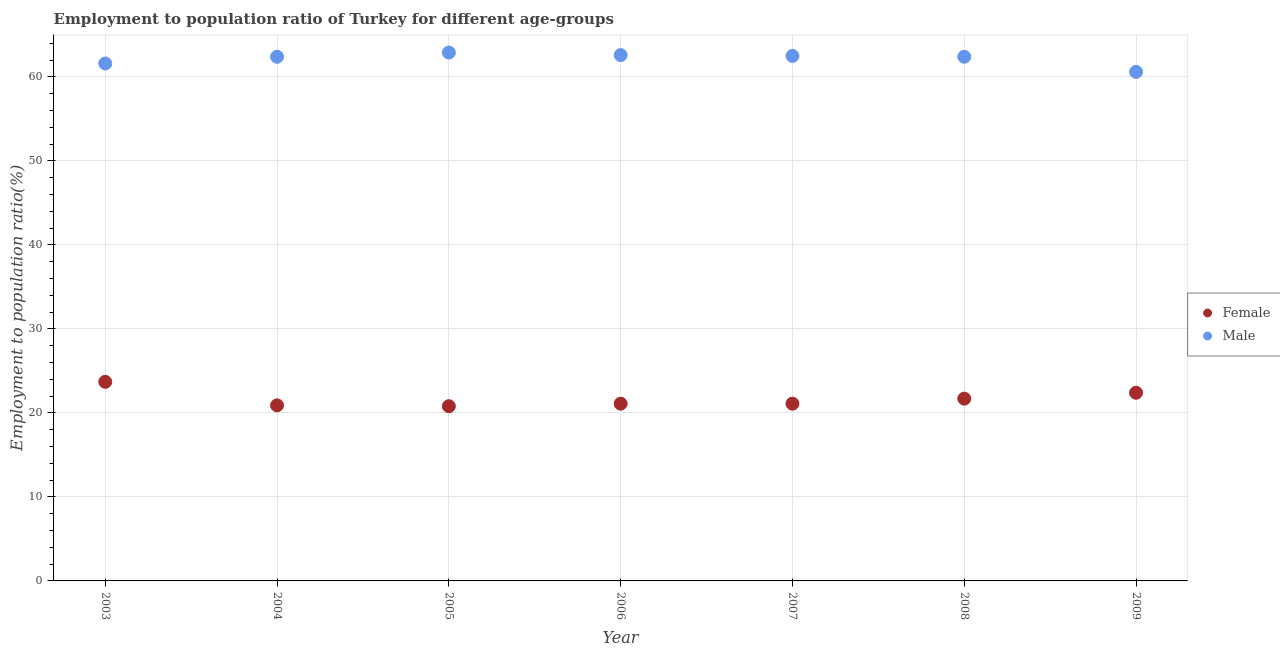Is the number of dotlines equal to the number of legend labels?
Your answer should be compact. Yes. What is the employment to population ratio(male) in 2008?
Give a very brief answer. 62.4. Across all years, what is the maximum employment to population ratio(female)?
Your answer should be very brief. 23.7. Across all years, what is the minimum employment to population ratio(female)?
Give a very brief answer. 20.8. In which year was the employment to population ratio(female) maximum?
Give a very brief answer. 2003. What is the total employment to population ratio(female) in the graph?
Your response must be concise. 151.7. What is the difference between the employment to population ratio(female) in 2003 and that in 2005?
Your answer should be compact. 2.9. What is the difference between the employment to population ratio(female) in 2008 and the employment to population ratio(male) in 2009?
Give a very brief answer. -38.9. What is the average employment to population ratio(female) per year?
Give a very brief answer. 21.67. In the year 2003, what is the difference between the employment to population ratio(female) and employment to population ratio(male)?
Provide a short and direct response. -37.9. In how many years, is the employment to population ratio(female) greater than 46 %?
Offer a terse response. 0. What is the ratio of the employment to population ratio(male) in 2004 to that in 2008?
Offer a very short reply. 1. Is the employment to population ratio(male) in 2004 less than that in 2005?
Offer a terse response. Yes. Is the difference between the employment to population ratio(female) in 2004 and 2007 greater than the difference between the employment to population ratio(male) in 2004 and 2007?
Make the answer very short. No. What is the difference between the highest and the second highest employment to population ratio(female)?
Keep it short and to the point. 1.3. What is the difference between the highest and the lowest employment to population ratio(female)?
Provide a short and direct response. 2.9. In how many years, is the employment to population ratio(female) greater than the average employment to population ratio(female) taken over all years?
Offer a terse response. 3. Is the employment to population ratio(female) strictly greater than the employment to population ratio(male) over the years?
Provide a short and direct response. No. How many years are there in the graph?
Your response must be concise. 7. Does the graph contain grids?
Provide a short and direct response. Yes. How are the legend labels stacked?
Your answer should be very brief. Vertical. What is the title of the graph?
Keep it short and to the point. Employment to population ratio of Turkey for different age-groups. What is the label or title of the Y-axis?
Provide a succinct answer. Employment to population ratio(%). What is the Employment to population ratio(%) of Female in 2003?
Ensure brevity in your answer.  23.7. What is the Employment to population ratio(%) in Male in 2003?
Provide a short and direct response. 61.6. What is the Employment to population ratio(%) of Female in 2004?
Your response must be concise. 20.9. What is the Employment to population ratio(%) in Male in 2004?
Provide a succinct answer. 62.4. What is the Employment to population ratio(%) in Female in 2005?
Ensure brevity in your answer.  20.8. What is the Employment to population ratio(%) of Male in 2005?
Offer a terse response. 62.9. What is the Employment to population ratio(%) of Female in 2006?
Provide a succinct answer. 21.1. What is the Employment to population ratio(%) in Male in 2006?
Your answer should be compact. 62.6. What is the Employment to population ratio(%) of Female in 2007?
Offer a very short reply. 21.1. What is the Employment to population ratio(%) in Male in 2007?
Offer a very short reply. 62.5. What is the Employment to population ratio(%) of Female in 2008?
Your response must be concise. 21.7. What is the Employment to population ratio(%) of Male in 2008?
Give a very brief answer. 62.4. What is the Employment to population ratio(%) in Female in 2009?
Ensure brevity in your answer.  22.4. What is the Employment to population ratio(%) in Male in 2009?
Your answer should be compact. 60.6. Across all years, what is the maximum Employment to population ratio(%) in Female?
Provide a succinct answer. 23.7. Across all years, what is the maximum Employment to population ratio(%) in Male?
Provide a short and direct response. 62.9. Across all years, what is the minimum Employment to population ratio(%) in Female?
Ensure brevity in your answer.  20.8. Across all years, what is the minimum Employment to population ratio(%) in Male?
Give a very brief answer. 60.6. What is the total Employment to population ratio(%) in Female in the graph?
Offer a very short reply. 151.7. What is the total Employment to population ratio(%) in Male in the graph?
Your answer should be compact. 435. What is the difference between the Employment to population ratio(%) of Female in 2003 and that in 2006?
Provide a succinct answer. 2.6. What is the difference between the Employment to population ratio(%) in Male in 2003 and that in 2007?
Ensure brevity in your answer.  -0.9. What is the difference between the Employment to population ratio(%) of Male in 2003 and that in 2008?
Your answer should be compact. -0.8. What is the difference between the Employment to population ratio(%) in Female in 2004 and that in 2006?
Keep it short and to the point. -0.2. What is the difference between the Employment to population ratio(%) in Female in 2004 and that in 2008?
Offer a terse response. -0.8. What is the difference between the Employment to population ratio(%) of Female in 2004 and that in 2009?
Offer a terse response. -1.5. What is the difference between the Employment to population ratio(%) in Male in 2004 and that in 2009?
Offer a terse response. 1.8. What is the difference between the Employment to population ratio(%) of Male in 2005 and that in 2007?
Provide a short and direct response. 0.4. What is the difference between the Employment to population ratio(%) in Female in 2005 and that in 2008?
Your answer should be compact. -0.9. What is the difference between the Employment to population ratio(%) in Male in 2005 and that in 2008?
Keep it short and to the point. 0.5. What is the difference between the Employment to population ratio(%) in Male in 2006 and that in 2007?
Your response must be concise. 0.1. What is the difference between the Employment to population ratio(%) in Female in 2006 and that in 2008?
Offer a very short reply. -0.6. What is the difference between the Employment to population ratio(%) in Female in 2006 and that in 2009?
Keep it short and to the point. -1.3. What is the difference between the Employment to population ratio(%) in Male in 2006 and that in 2009?
Your answer should be compact. 2. What is the difference between the Employment to population ratio(%) in Female in 2007 and that in 2009?
Make the answer very short. -1.3. What is the difference between the Employment to population ratio(%) in Male in 2007 and that in 2009?
Keep it short and to the point. 1.9. What is the difference between the Employment to population ratio(%) of Male in 2008 and that in 2009?
Provide a succinct answer. 1.8. What is the difference between the Employment to population ratio(%) in Female in 2003 and the Employment to population ratio(%) in Male in 2004?
Provide a short and direct response. -38.7. What is the difference between the Employment to population ratio(%) in Female in 2003 and the Employment to population ratio(%) in Male in 2005?
Provide a short and direct response. -39.2. What is the difference between the Employment to population ratio(%) of Female in 2003 and the Employment to population ratio(%) of Male in 2006?
Give a very brief answer. -38.9. What is the difference between the Employment to population ratio(%) in Female in 2003 and the Employment to population ratio(%) in Male in 2007?
Give a very brief answer. -38.8. What is the difference between the Employment to population ratio(%) of Female in 2003 and the Employment to population ratio(%) of Male in 2008?
Make the answer very short. -38.7. What is the difference between the Employment to population ratio(%) of Female in 2003 and the Employment to population ratio(%) of Male in 2009?
Ensure brevity in your answer.  -36.9. What is the difference between the Employment to population ratio(%) in Female in 2004 and the Employment to population ratio(%) in Male in 2005?
Offer a terse response. -42. What is the difference between the Employment to population ratio(%) of Female in 2004 and the Employment to population ratio(%) of Male in 2006?
Keep it short and to the point. -41.7. What is the difference between the Employment to population ratio(%) in Female in 2004 and the Employment to population ratio(%) in Male in 2007?
Provide a short and direct response. -41.6. What is the difference between the Employment to population ratio(%) of Female in 2004 and the Employment to population ratio(%) of Male in 2008?
Provide a short and direct response. -41.5. What is the difference between the Employment to population ratio(%) in Female in 2004 and the Employment to population ratio(%) in Male in 2009?
Provide a succinct answer. -39.7. What is the difference between the Employment to population ratio(%) of Female in 2005 and the Employment to population ratio(%) of Male in 2006?
Provide a short and direct response. -41.8. What is the difference between the Employment to population ratio(%) of Female in 2005 and the Employment to population ratio(%) of Male in 2007?
Provide a succinct answer. -41.7. What is the difference between the Employment to population ratio(%) of Female in 2005 and the Employment to population ratio(%) of Male in 2008?
Your answer should be compact. -41.6. What is the difference between the Employment to population ratio(%) in Female in 2005 and the Employment to population ratio(%) in Male in 2009?
Ensure brevity in your answer.  -39.8. What is the difference between the Employment to population ratio(%) of Female in 2006 and the Employment to population ratio(%) of Male in 2007?
Give a very brief answer. -41.4. What is the difference between the Employment to population ratio(%) in Female in 2006 and the Employment to population ratio(%) in Male in 2008?
Provide a succinct answer. -41.3. What is the difference between the Employment to population ratio(%) in Female in 2006 and the Employment to population ratio(%) in Male in 2009?
Make the answer very short. -39.5. What is the difference between the Employment to population ratio(%) of Female in 2007 and the Employment to population ratio(%) of Male in 2008?
Your answer should be very brief. -41.3. What is the difference between the Employment to population ratio(%) in Female in 2007 and the Employment to population ratio(%) in Male in 2009?
Keep it short and to the point. -39.5. What is the difference between the Employment to population ratio(%) in Female in 2008 and the Employment to population ratio(%) in Male in 2009?
Your answer should be compact. -38.9. What is the average Employment to population ratio(%) in Female per year?
Your answer should be compact. 21.67. What is the average Employment to population ratio(%) in Male per year?
Give a very brief answer. 62.14. In the year 2003, what is the difference between the Employment to population ratio(%) of Female and Employment to population ratio(%) of Male?
Give a very brief answer. -37.9. In the year 2004, what is the difference between the Employment to population ratio(%) in Female and Employment to population ratio(%) in Male?
Keep it short and to the point. -41.5. In the year 2005, what is the difference between the Employment to population ratio(%) of Female and Employment to population ratio(%) of Male?
Ensure brevity in your answer.  -42.1. In the year 2006, what is the difference between the Employment to population ratio(%) in Female and Employment to population ratio(%) in Male?
Keep it short and to the point. -41.5. In the year 2007, what is the difference between the Employment to population ratio(%) of Female and Employment to population ratio(%) of Male?
Keep it short and to the point. -41.4. In the year 2008, what is the difference between the Employment to population ratio(%) in Female and Employment to population ratio(%) in Male?
Provide a succinct answer. -40.7. In the year 2009, what is the difference between the Employment to population ratio(%) in Female and Employment to population ratio(%) in Male?
Offer a very short reply. -38.2. What is the ratio of the Employment to population ratio(%) in Female in 2003 to that in 2004?
Make the answer very short. 1.13. What is the ratio of the Employment to population ratio(%) in Male in 2003 to that in 2004?
Your answer should be very brief. 0.99. What is the ratio of the Employment to population ratio(%) in Female in 2003 to that in 2005?
Your response must be concise. 1.14. What is the ratio of the Employment to population ratio(%) of Male in 2003 to that in 2005?
Make the answer very short. 0.98. What is the ratio of the Employment to population ratio(%) in Female in 2003 to that in 2006?
Provide a succinct answer. 1.12. What is the ratio of the Employment to population ratio(%) of Male in 2003 to that in 2006?
Provide a short and direct response. 0.98. What is the ratio of the Employment to population ratio(%) in Female in 2003 to that in 2007?
Provide a short and direct response. 1.12. What is the ratio of the Employment to population ratio(%) in Male in 2003 to that in 2007?
Provide a short and direct response. 0.99. What is the ratio of the Employment to population ratio(%) in Female in 2003 to that in 2008?
Your answer should be very brief. 1.09. What is the ratio of the Employment to population ratio(%) in Male in 2003 to that in 2008?
Your response must be concise. 0.99. What is the ratio of the Employment to population ratio(%) in Female in 2003 to that in 2009?
Provide a short and direct response. 1.06. What is the ratio of the Employment to population ratio(%) of Male in 2003 to that in 2009?
Keep it short and to the point. 1.02. What is the ratio of the Employment to population ratio(%) of Male in 2004 to that in 2005?
Provide a succinct answer. 0.99. What is the ratio of the Employment to population ratio(%) of Female in 2004 to that in 2006?
Keep it short and to the point. 0.99. What is the ratio of the Employment to population ratio(%) of Female in 2004 to that in 2008?
Your answer should be compact. 0.96. What is the ratio of the Employment to population ratio(%) in Female in 2004 to that in 2009?
Offer a very short reply. 0.93. What is the ratio of the Employment to population ratio(%) of Male in 2004 to that in 2009?
Make the answer very short. 1.03. What is the ratio of the Employment to population ratio(%) of Female in 2005 to that in 2006?
Your answer should be compact. 0.99. What is the ratio of the Employment to population ratio(%) in Female in 2005 to that in 2007?
Provide a succinct answer. 0.99. What is the ratio of the Employment to population ratio(%) of Male in 2005 to that in 2007?
Give a very brief answer. 1.01. What is the ratio of the Employment to population ratio(%) of Female in 2005 to that in 2008?
Your answer should be very brief. 0.96. What is the ratio of the Employment to population ratio(%) in Female in 2005 to that in 2009?
Your response must be concise. 0.93. What is the ratio of the Employment to population ratio(%) of Male in 2005 to that in 2009?
Your answer should be compact. 1.04. What is the ratio of the Employment to population ratio(%) in Male in 2006 to that in 2007?
Offer a terse response. 1. What is the ratio of the Employment to population ratio(%) of Female in 2006 to that in 2008?
Offer a terse response. 0.97. What is the ratio of the Employment to population ratio(%) in Male in 2006 to that in 2008?
Your answer should be very brief. 1. What is the ratio of the Employment to population ratio(%) in Female in 2006 to that in 2009?
Keep it short and to the point. 0.94. What is the ratio of the Employment to population ratio(%) of Male in 2006 to that in 2009?
Provide a succinct answer. 1.03. What is the ratio of the Employment to population ratio(%) in Female in 2007 to that in 2008?
Your answer should be very brief. 0.97. What is the ratio of the Employment to population ratio(%) in Male in 2007 to that in 2008?
Give a very brief answer. 1. What is the ratio of the Employment to population ratio(%) in Female in 2007 to that in 2009?
Your answer should be very brief. 0.94. What is the ratio of the Employment to population ratio(%) of Male in 2007 to that in 2009?
Your response must be concise. 1.03. What is the ratio of the Employment to population ratio(%) in Female in 2008 to that in 2009?
Make the answer very short. 0.97. What is the ratio of the Employment to population ratio(%) of Male in 2008 to that in 2009?
Your answer should be very brief. 1.03. What is the difference between the highest and the second highest Employment to population ratio(%) in Female?
Ensure brevity in your answer.  1.3. What is the difference between the highest and the lowest Employment to population ratio(%) of Male?
Offer a very short reply. 2.3. 